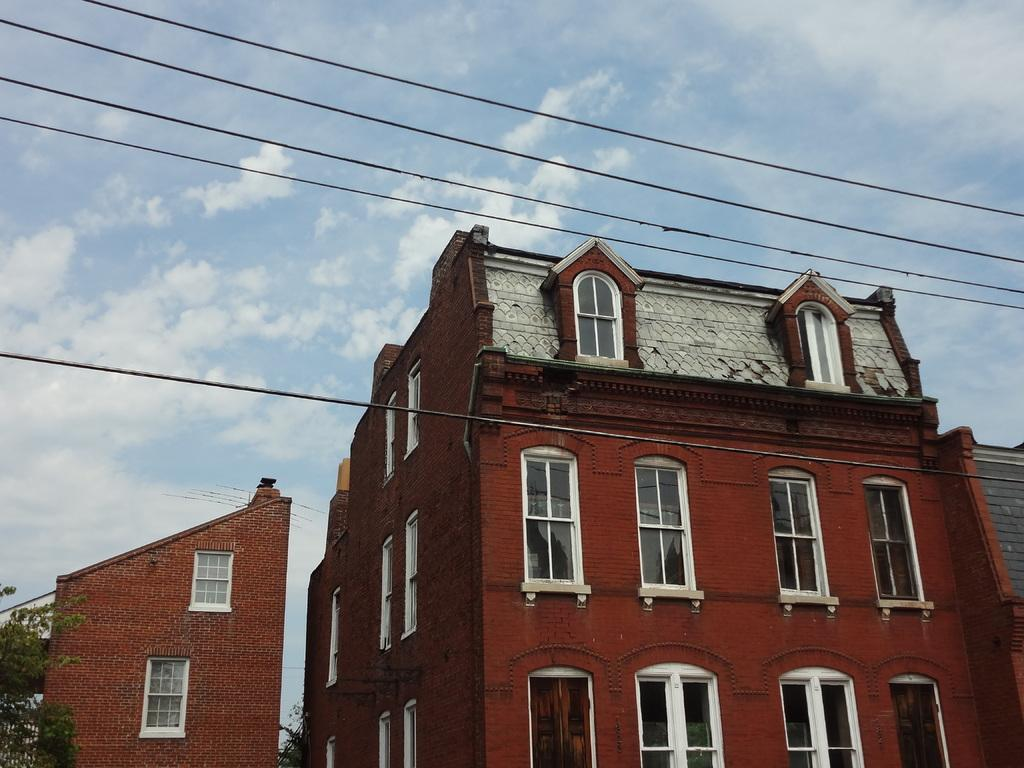What type of structures are in the foreground of the image? There are buildings in the foreground of the image. What type of vegetation is at the bottom of the image? There are trees at the bottom of the image. What is visible at the top of the image? Cables and the sky are visible at the top of the image. What can be seen in the sky? There is a cloud in the sky. Can you tell me how many hands are holding the cloud in the image? There are no hands present in the image, and therefore no hands are holding the cloud. What type of vegetable is being carried by the porter in the image? There is no porter or vegetable present in the image. 